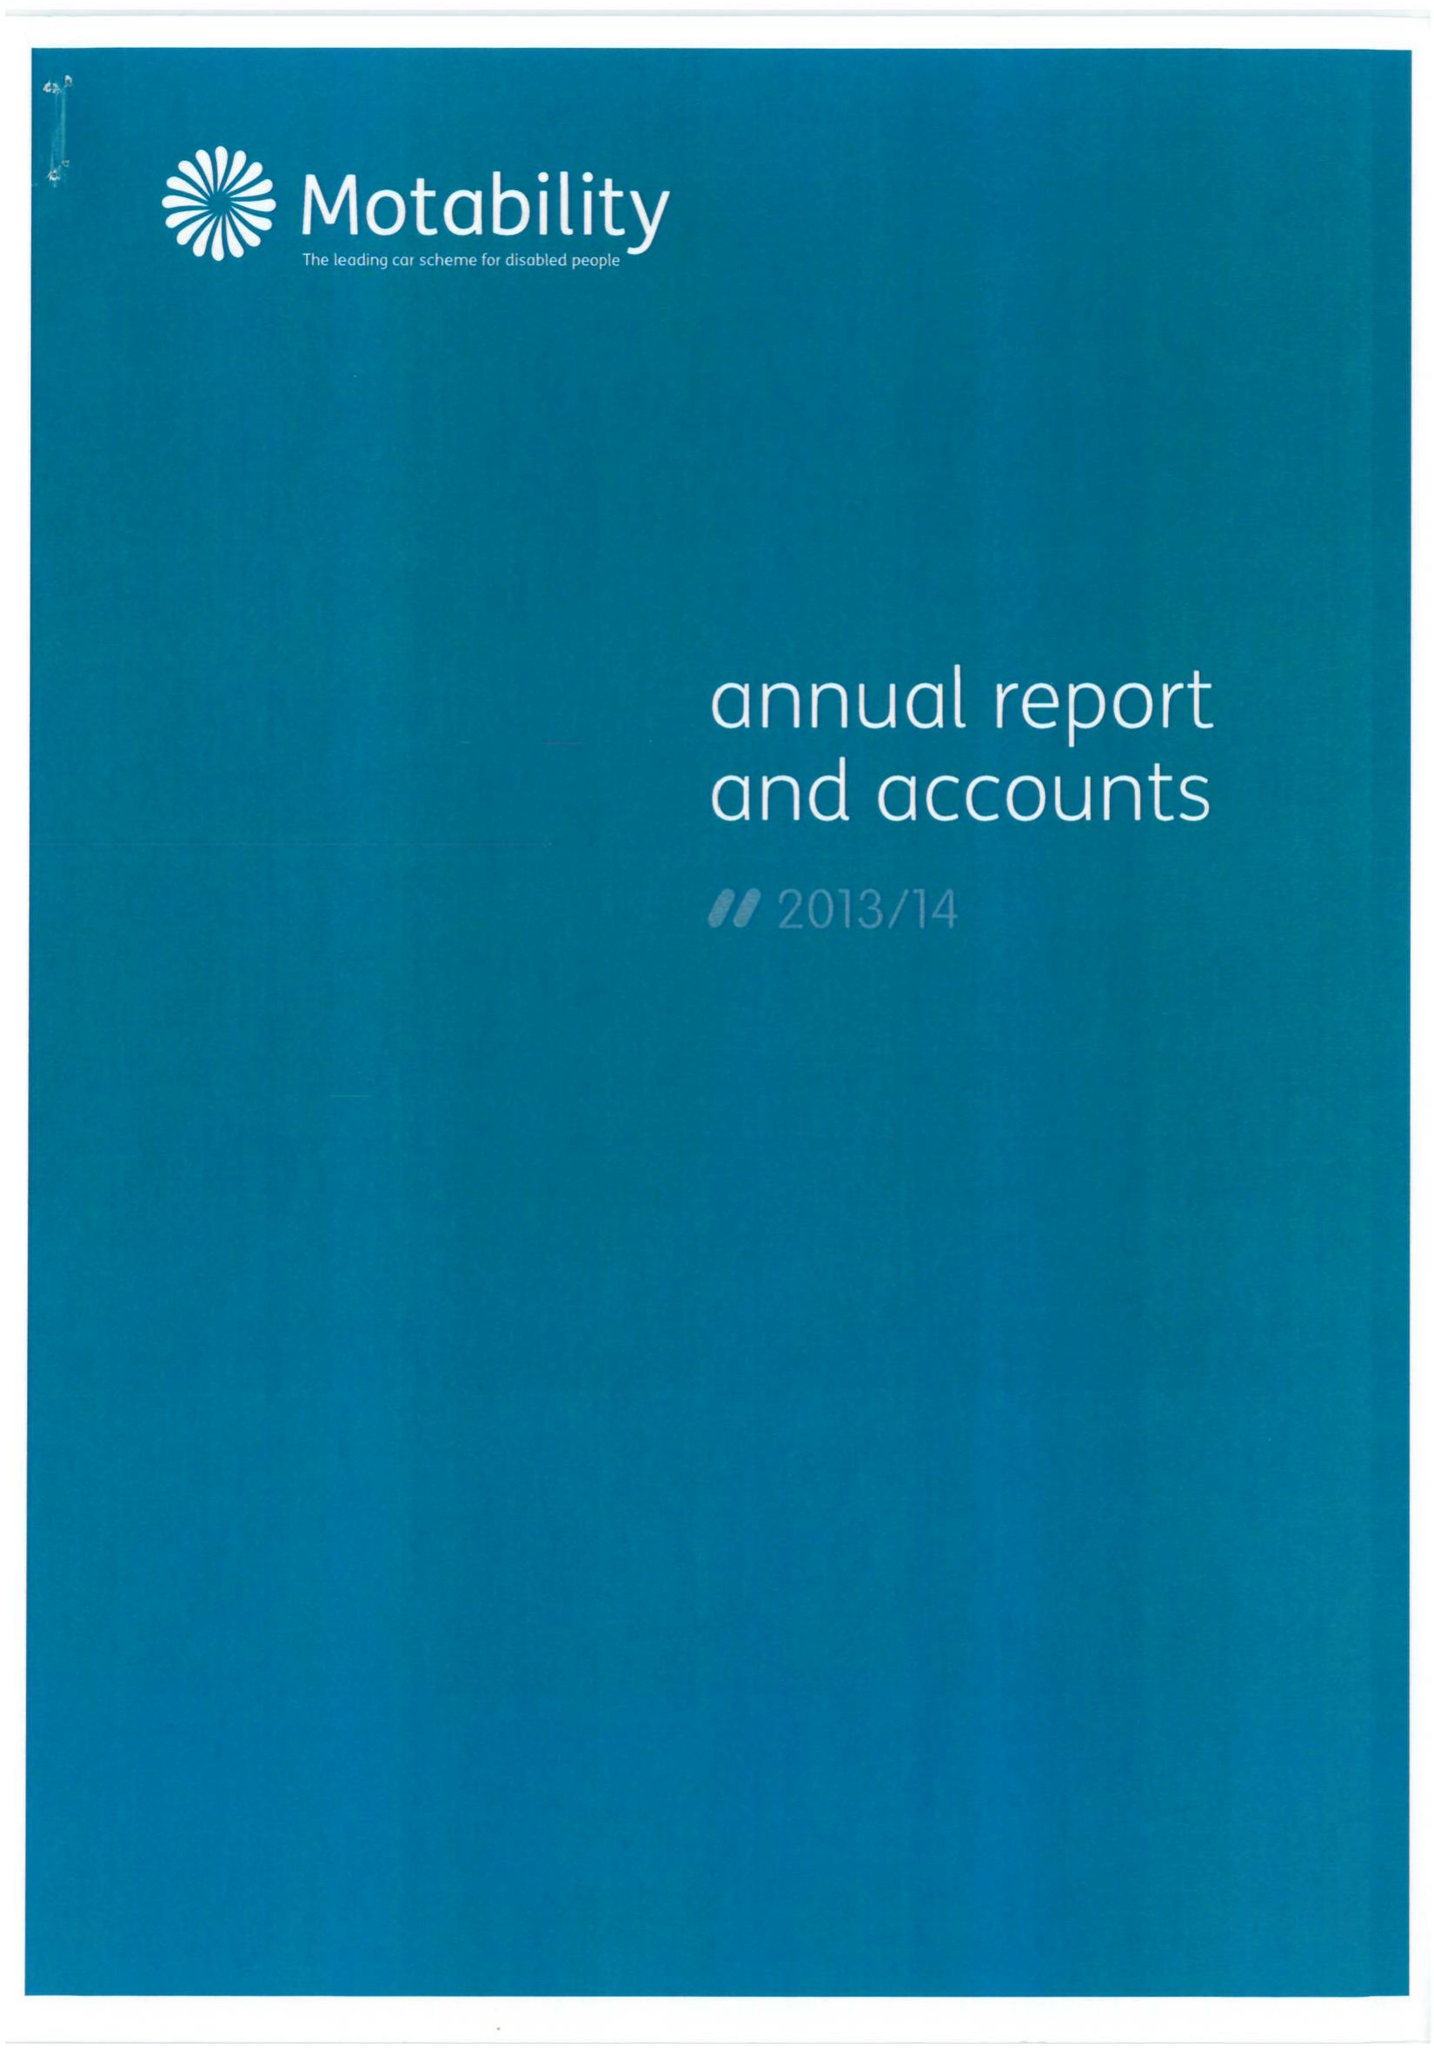What is the value for the income_annually_in_british_pounds?
Answer the question using a single word or phrase. 29527000.00 